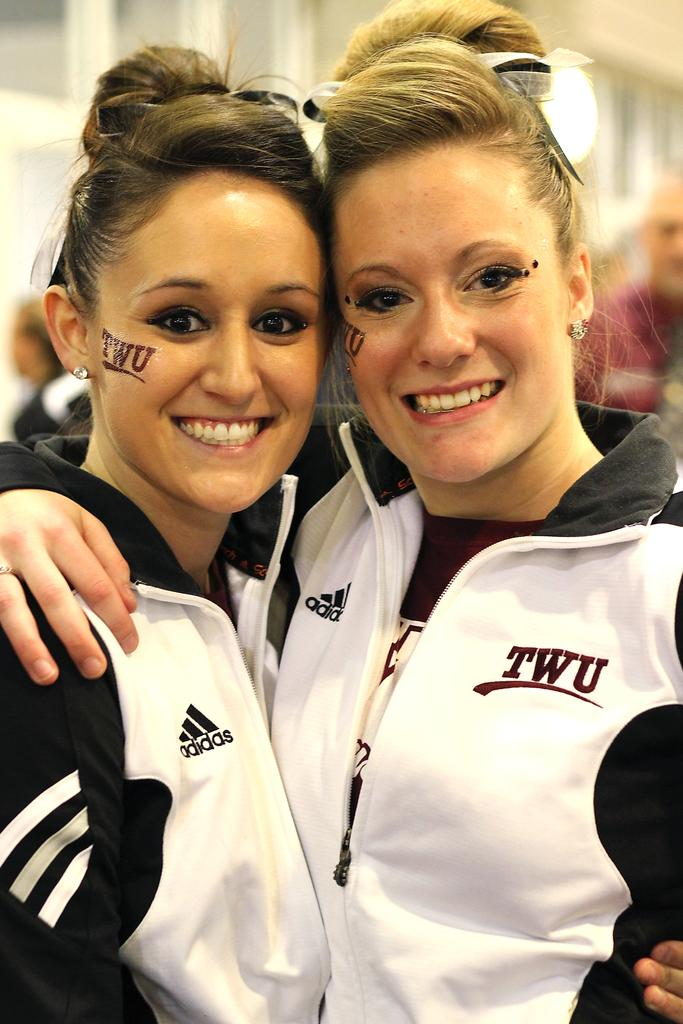<image>
Provide a brief description of the given image. Two women wearing Adidas jackets are posing for a picture. 